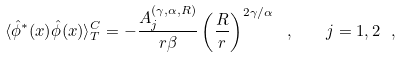Convert formula to latex. <formula><loc_0><loc_0><loc_500><loc_500>\langle \hat { \phi } ^ { \ast } ( x ) \hat { \phi } ( x ) \rangle _ { T } ^ { C } = - \frac { A _ { j } ^ { ( \gamma , \alpha , R ) } } { r \beta } \left ( \frac { R } { r } \right ) ^ { 2 \gamma / \alpha } \ , \quad j = 1 , 2 \ ,</formula> 